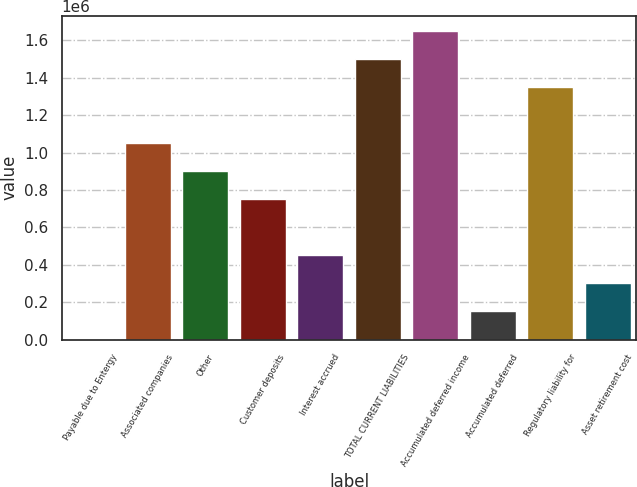<chart> <loc_0><loc_0><loc_500><loc_500><bar_chart><fcel>Payable due to Entergy<fcel>Associated companies<fcel>Other<fcel>Customer deposits<fcel>Interest accrued<fcel>TOTAL CURRENT LIABILITIES<fcel>Accumulated deferred income<fcel>Accumulated deferred<fcel>Regulatory liability for<fcel>Asset retirement cost<nl><fcel>2077<fcel>1.04911e+06<fcel>899532<fcel>749956<fcel>450805<fcel>1.49784e+06<fcel>1.64741e+06<fcel>151653<fcel>1.34826e+06<fcel>301229<nl></chart> 